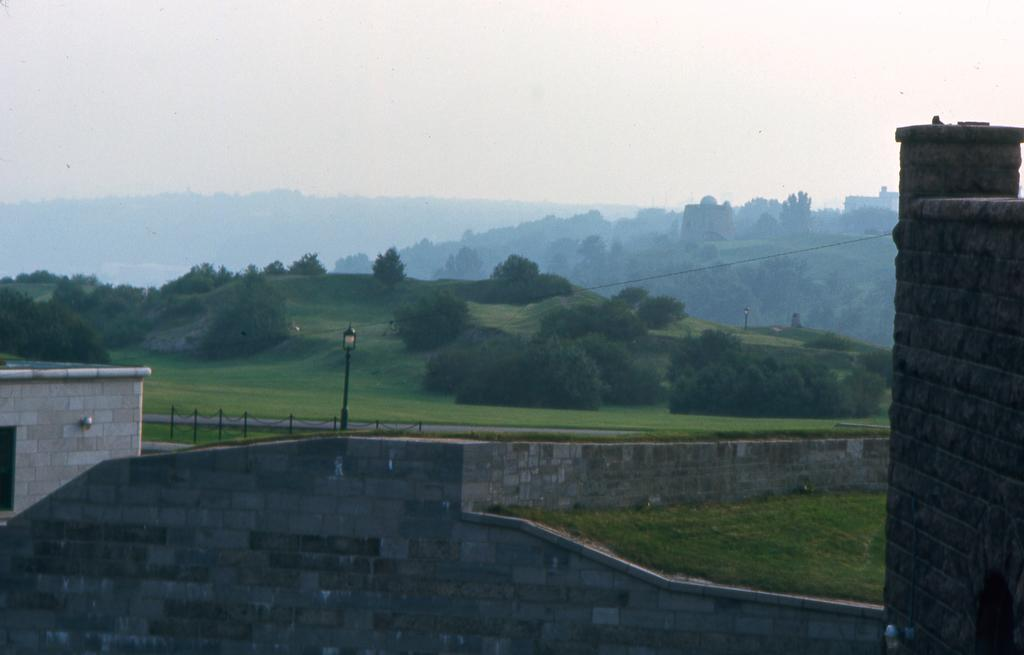What type of structures can be seen in the image? There are buildings in the image. What architectural feature is present in the image? There is a wall in the image. What type of lighting is visible in the image? There is a lamp in the image. What safety feature can be seen in the image? There is a railing in the image. What type of vegetation is present in the image? There are trees and grass in the image. What natural landmark is visible in the image? There are mountains in the image. What part of the natural environment is visible in the image? The sky is visible in the image. Can you tell me how many cups of rice are being cooked in the image? There is no rice or cooking activity present in the image. Is there a lake visible in the image? No, there is no lake present in the image. 